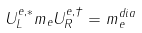Convert formula to latex. <formula><loc_0><loc_0><loc_500><loc_500>U ^ { e , * } _ { L } m _ { e } U _ { R } ^ { e , \dagger } = m ^ { d i a } _ { e }</formula> 